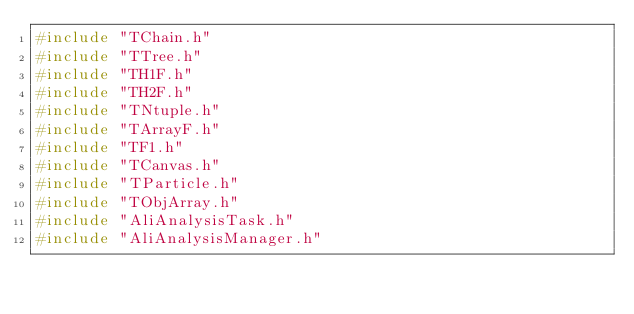<code> <loc_0><loc_0><loc_500><loc_500><_C++_>#include "TChain.h"
#include "TTree.h"
#include "TH1F.h"
#include "TH2F.h"
#include "TNtuple.h"
#include "TArrayF.h"
#include "TF1.h"
#include "TCanvas.h"
#include "TParticle.h"
#include "TObjArray.h"
#include "AliAnalysisTask.h"
#include "AliAnalysisManager.h"</code> 